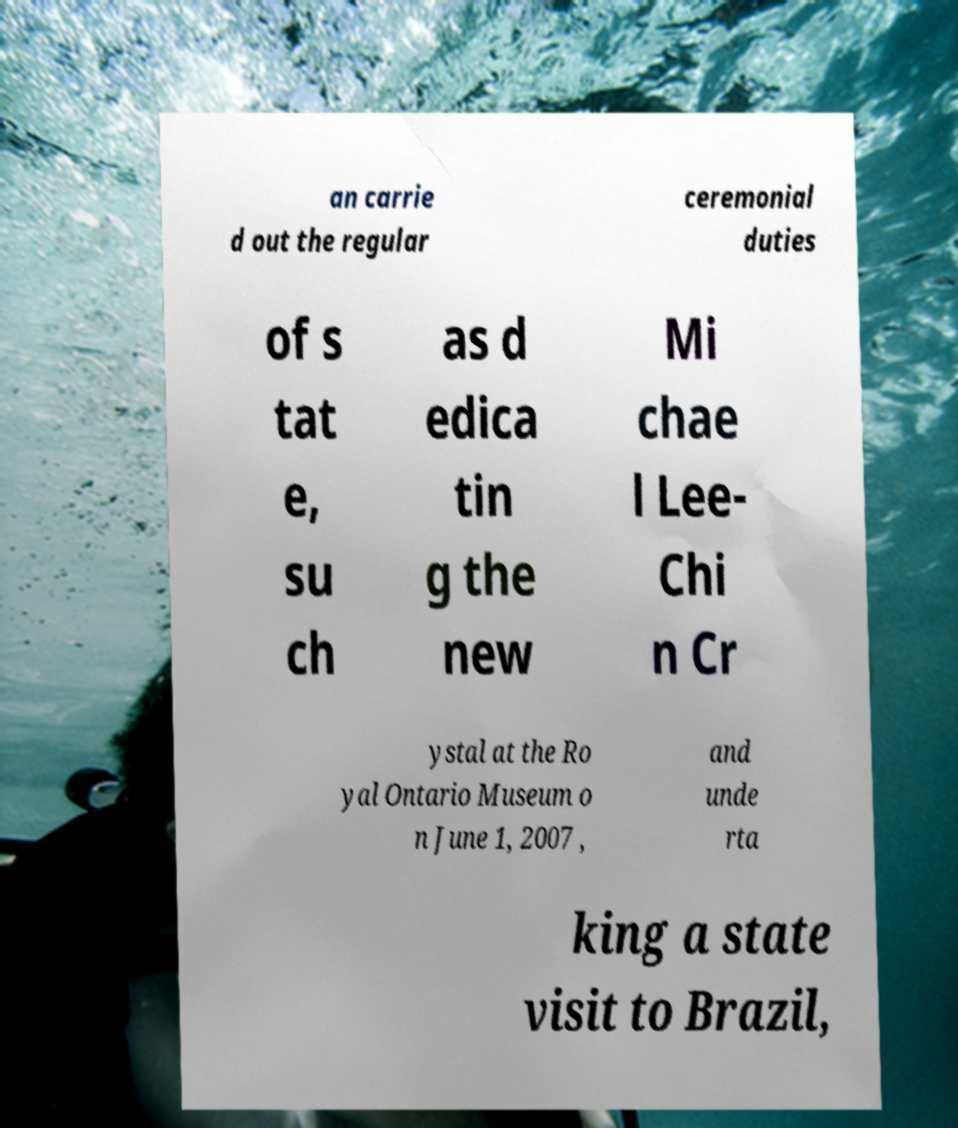I need the written content from this picture converted into text. Can you do that? an carrie d out the regular ceremonial duties of s tat e, su ch as d edica tin g the new Mi chae l Lee- Chi n Cr ystal at the Ro yal Ontario Museum o n June 1, 2007 , and unde rta king a state visit to Brazil, 